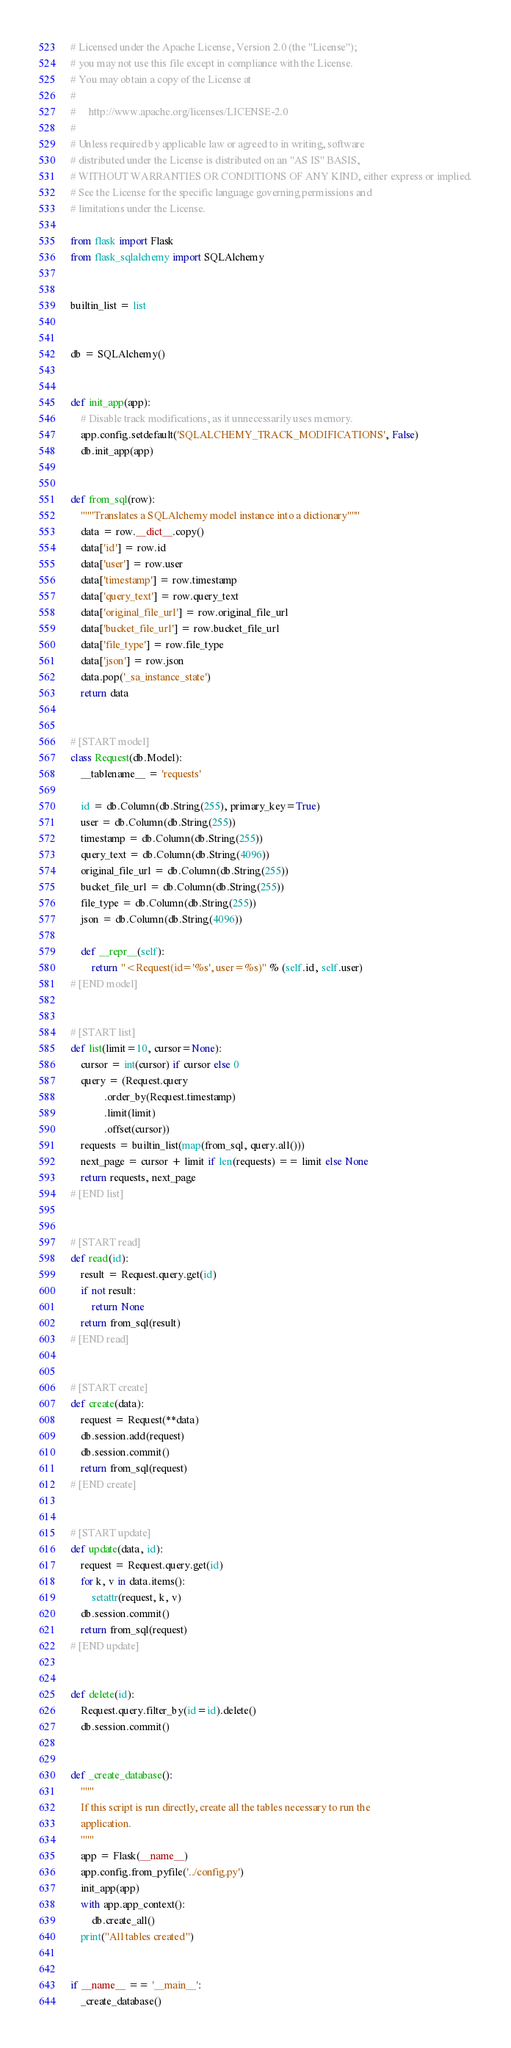<code> <loc_0><loc_0><loc_500><loc_500><_Python_># Licensed under the Apache License, Version 2.0 (the "License");
# you may not use this file except in compliance with the License.
# You may obtain a copy of the License at
#
#     http://www.apache.org/licenses/LICENSE-2.0
#
# Unless required by applicable law or agreed to in writing, software
# distributed under the License is distributed on an "AS IS" BASIS,
# WITHOUT WARRANTIES OR CONDITIONS OF ANY KIND, either express or implied.
# See the License for the specific language governing permissions and
# limitations under the License.

from flask import Flask
from flask_sqlalchemy import SQLAlchemy


builtin_list = list


db = SQLAlchemy()


def init_app(app):
    # Disable track modifications, as it unnecessarily uses memory.
    app.config.setdefault('SQLALCHEMY_TRACK_MODIFICATIONS', False)
    db.init_app(app)


def from_sql(row):
    """Translates a SQLAlchemy model instance into a dictionary"""
    data = row.__dict__.copy()
    data['id'] = row.id
    data['user'] = row.user 
    data['timestamp'] = row.timestamp 
    data['query_text'] = row.query_text 
    data['original_file_url'] = row.original_file_url
    data['bucket_file_url'] = row.bucket_file_url
    data['file_type'] = row.file_type
    data['json'] = row.json 
    data.pop('_sa_instance_state')
    return data


# [START model]
class Request(db.Model):
    __tablename__ = 'requests'

    id = db.Column(db.String(255), primary_key=True)
    user = db.Column(db.String(255))
    timestamp = db.Column(db.String(255))
    query_text = db.Column(db.String(4096))
    original_file_url = db.Column(db.String(255))
    bucket_file_url = db.Column(db.String(255))
    file_type = db.Column(db.String(255))
    json = db.Column(db.String(4096))

    def __repr__(self):
        return "<Request(id='%s', user=%s)" % (self.id, self.user)
# [END model]


# [START list]
def list(limit=10, cursor=None):
    cursor = int(cursor) if cursor else 0
    query = (Request.query
             .order_by(Request.timestamp)
             .limit(limit)
             .offset(cursor))
    requests = builtin_list(map(from_sql, query.all()))
    next_page = cursor + limit if len(requests) == limit else None
    return requests, next_page
# [END list]


# [START read]
def read(id):
    result = Request.query.get(id)
    if not result:
        return None
    return from_sql(result)
# [END read]


# [START create]
def create(data):
    request = Request(**data)
    db.session.add(request)
    db.session.commit()
    return from_sql(request)
# [END create]


# [START update]
def update(data, id):
    request = Request.query.get(id)
    for k, v in data.items():
        setattr(request, k, v)
    db.session.commit()
    return from_sql(request)
# [END update]


def delete(id):
    Request.query.filter_by(id=id).delete()
    db.session.commit()


def _create_database():
    """
    If this script is run directly, create all the tables necessary to run the
    application.
    """
    app = Flask(__name__)
    app.config.from_pyfile('../config.py')
    init_app(app)
    with app.app_context():
        db.create_all()
    print("All tables created")


if __name__ == '__main__':
    _create_database()
</code> 